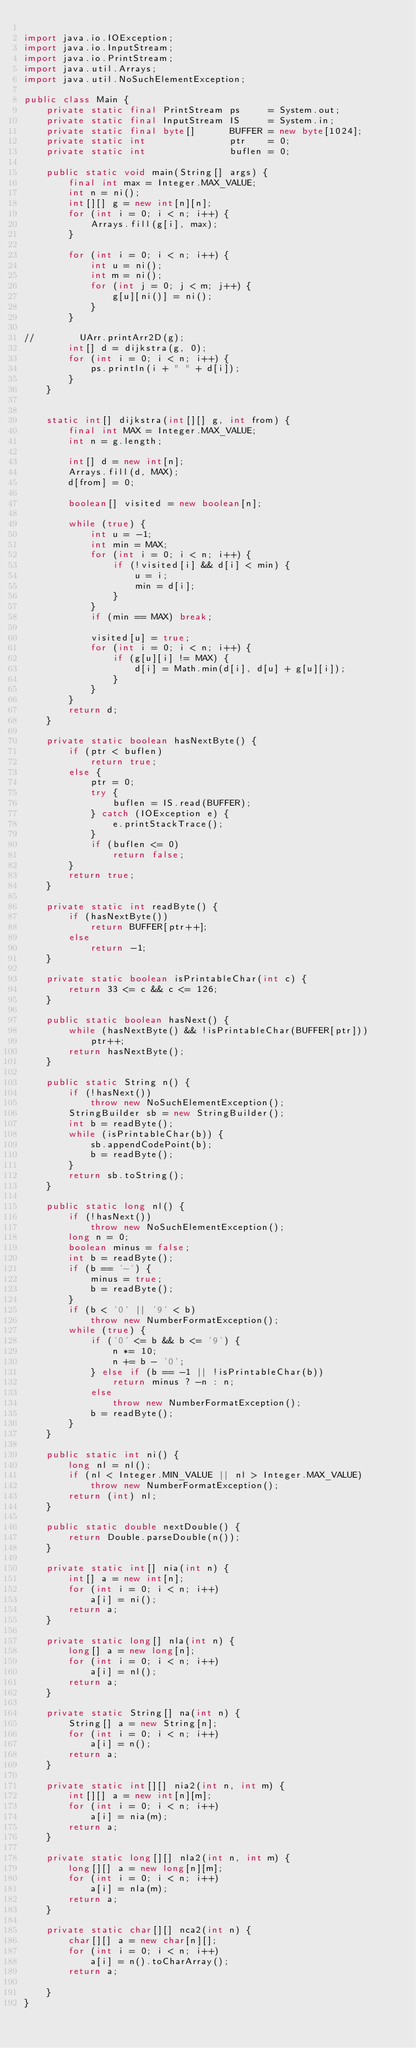Convert code to text. <code><loc_0><loc_0><loc_500><loc_500><_Java_>
import java.io.IOException;
import java.io.InputStream;
import java.io.PrintStream;
import java.util.Arrays;
import java.util.NoSuchElementException;

public class Main {
    private static final PrintStream ps     = System.out;
    private static final InputStream IS     = System.in;
    private static final byte[]      BUFFER = new byte[1024];
    private static int               ptr    = 0;
    private static int               buflen = 0;

    public static void main(String[] args) {
        final int max = Integer.MAX_VALUE;
        int n = ni();
        int[][] g = new int[n][n];
        for (int i = 0; i < n; i++) {
            Arrays.fill(g[i], max);
        }
        
        for (int i = 0; i < n; i++) {
            int u = ni();
            int m = ni();
            for (int j = 0; j < m; j++) {
                g[u][ni()] = ni();
            }
        }
        
//        UArr.printArr2D(g);
        int[] d = dijkstra(g, 0);
        for (int i = 0; i < n; i++) {
            ps.println(i + " " + d[i]);
        }
    }
    
    
    static int[] dijkstra(int[][] g, int from) {
        final int MAX = Integer.MAX_VALUE;
        int n = g.length;
        
        int[] d = new int[n];
        Arrays.fill(d, MAX);
        d[from] = 0;
        
        boolean[] visited = new boolean[n];
        
        while (true) {
            int u = -1;
            int min = MAX;
            for (int i = 0; i < n; i++) {
                if (!visited[i] && d[i] < min) {
                    u = i;
                    min = d[i];
                }
            }
            if (min == MAX) break;
            
            visited[u] = true;
            for (int i = 0; i < n; i++) {
                if (g[u][i] != MAX) {
                    d[i] = Math.min(d[i], d[u] + g[u][i]);
                }
            }
        }
        return d;
    }

    private static boolean hasNextByte() {
        if (ptr < buflen)
            return true;
        else {
            ptr = 0;
            try {
                buflen = IS.read(BUFFER);
            } catch (IOException e) {
                e.printStackTrace();
            }
            if (buflen <= 0)
                return false;
        }
        return true;
    }

    private static int readByte() {
        if (hasNextByte())
            return BUFFER[ptr++];
        else
            return -1;
    }

    private static boolean isPrintableChar(int c) {
        return 33 <= c && c <= 126;
    }

    public static boolean hasNext() {
        while (hasNextByte() && !isPrintableChar(BUFFER[ptr]))
            ptr++;
        return hasNextByte();
    }

    public static String n() {
        if (!hasNext())
            throw new NoSuchElementException();
        StringBuilder sb = new StringBuilder();
        int b = readByte();
        while (isPrintableChar(b)) {
            sb.appendCodePoint(b);
            b = readByte();
        }
        return sb.toString();
    }

    public static long nl() {
        if (!hasNext())
            throw new NoSuchElementException();
        long n = 0;
        boolean minus = false;
        int b = readByte();
        if (b == '-') {
            minus = true;
            b = readByte();
        }
        if (b < '0' || '9' < b)
            throw new NumberFormatException();
        while (true) {
            if ('0' <= b && b <= '9') {
                n *= 10;
                n += b - '0';
            } else if (b == -1 || !isPrintableChar(b))
                return minus ? -n : n;
            else
                throw new NumberFormatException();
            b = readByte();
        }
    }

    public static int ni() {
        long nl = nl();
        if (nl < Integer.MIN_VALUE || nl > Integer.MAX_VALUE)
            throw new NumberFormatException();
        return (int) nl;
    }

    public static double nextDouble() {
        return Double.parseDouble(n());
    }

    private static int[] nia(int n) {
        int[] a = new int[n];
        for (int i = 0; i < n; i++)
            a[i] = ni();
        return a;
    }

    private static long[] nla(int n) {
        long[] a = new long[n];
        for (int i = 0; i < n; i++)
            a[i] = nl();
        return a;
    }

    private static String[] na(int n) {
        String[] a = new String[n];
        for (int i = 0; i < n; i++)
            a[i] = n();
        return a;
    }

    private static int[][] nia2(int n, int m) {
        int[][] a = new int[n][m];
        for (int i = 0; i < n; i++)
            a[i] = nia(m);
        return a;
    }

    private static long[][] nla2(int n, int m) {
        long[][] a = new long[n][m];
        for (int i = 0; i < n; i++)
            a[i] = nla(m);
        return a;
    }

    private static char[][] nca2(int n) {
        char[][] a = new char[n][];
        for (int i = 0; i < n; i++)
            a[i] = n().toCharArray();
        return a;

    }
}

</code> 